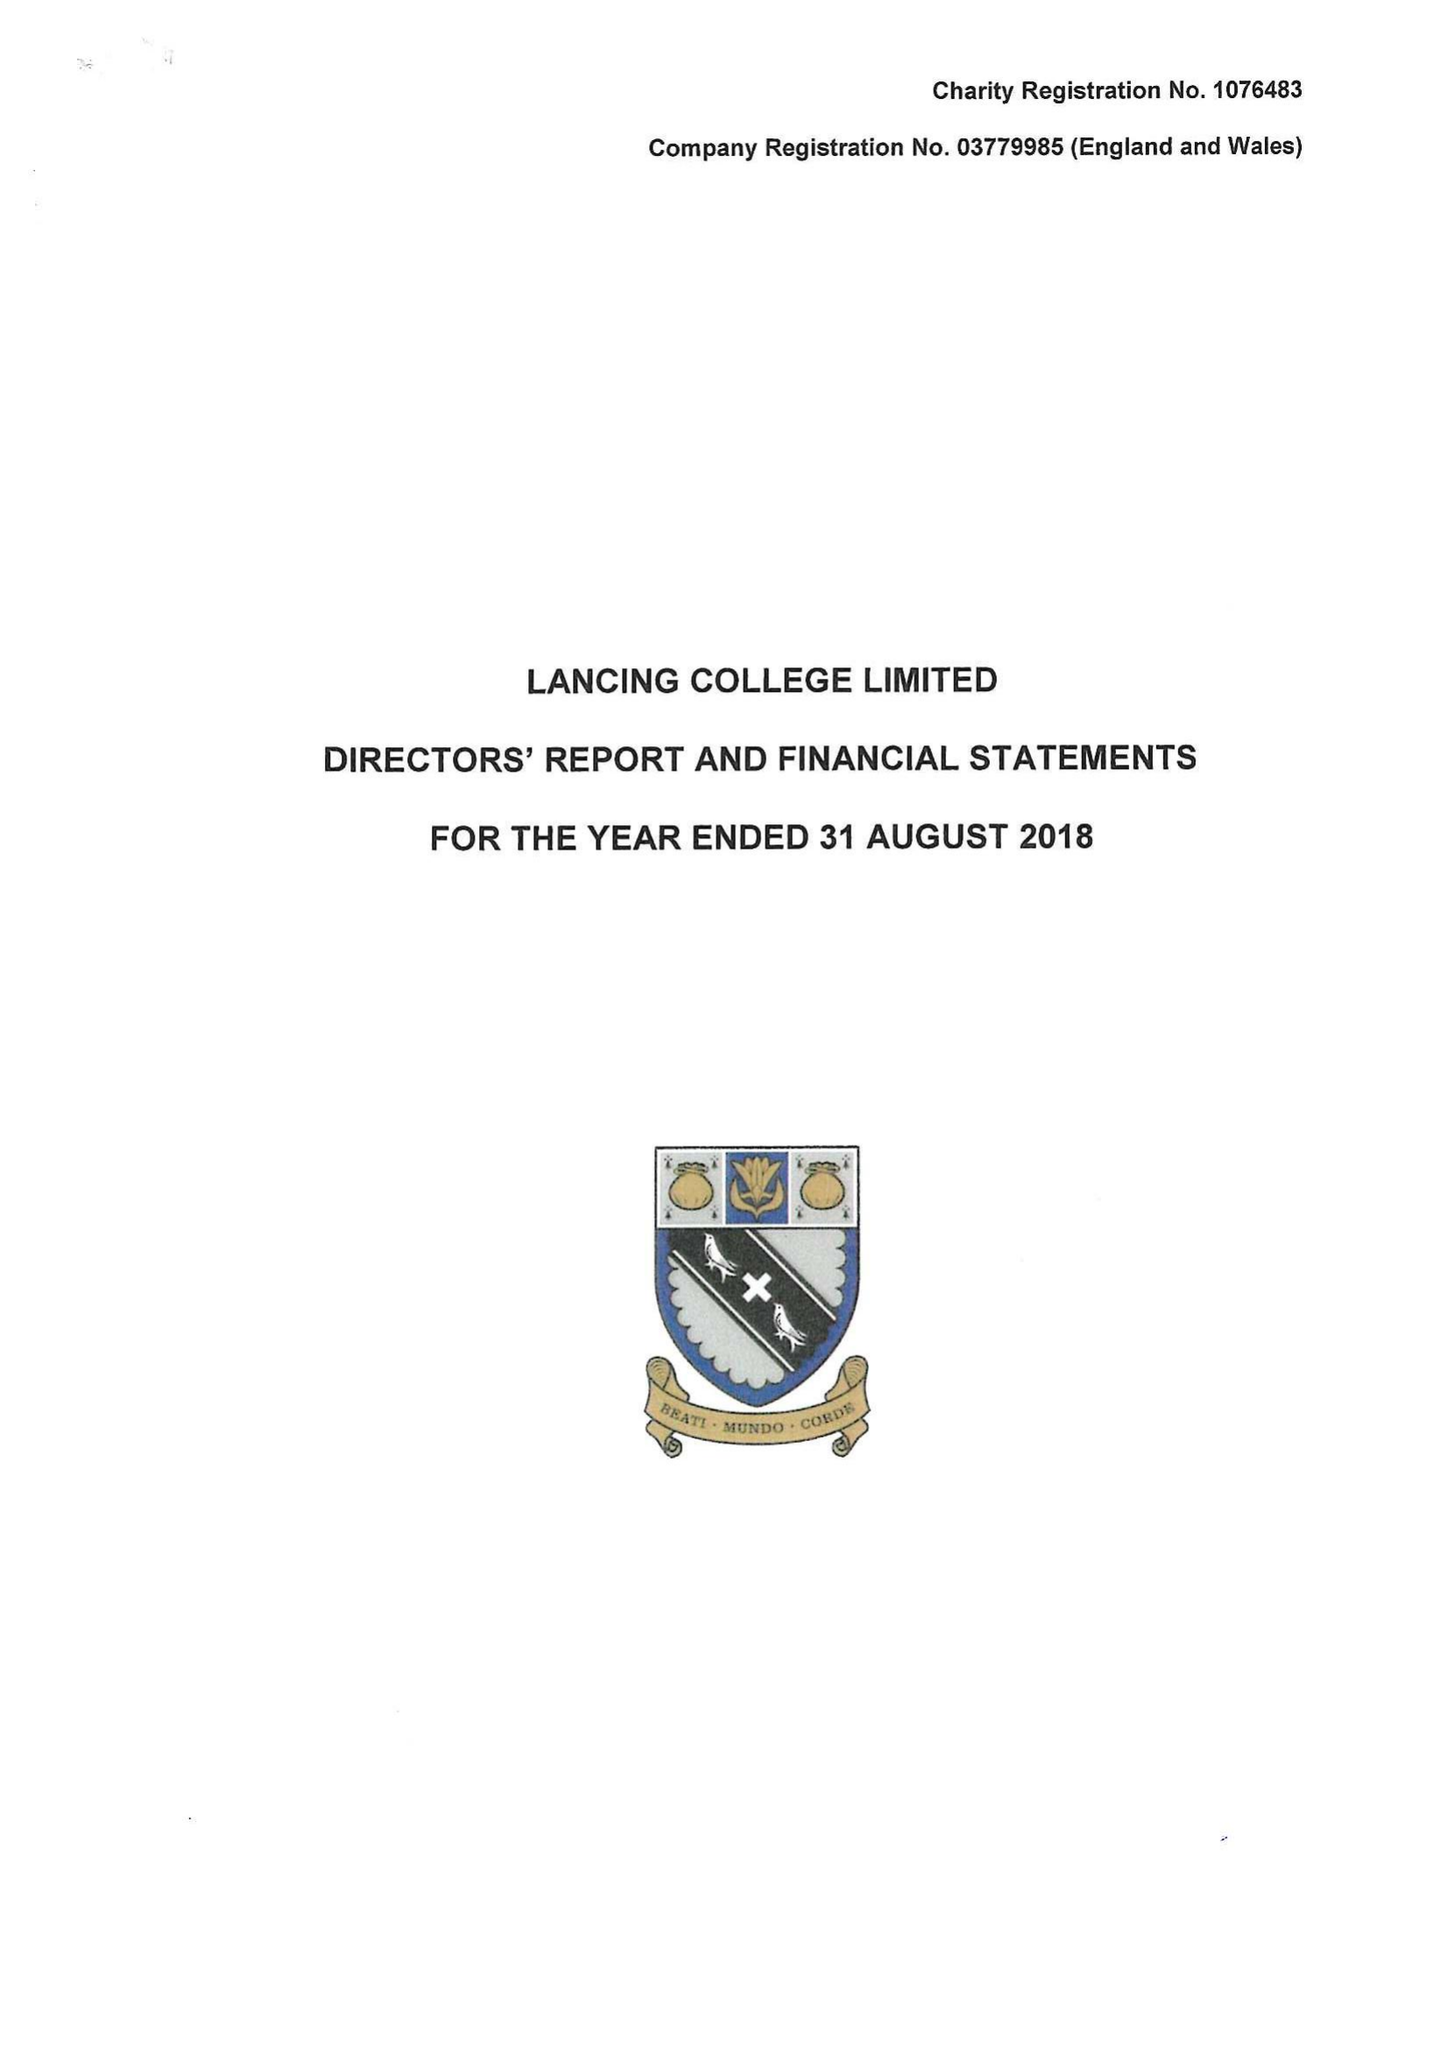What is the value for the address__postcode?
Answer the question using a single word or phrase. BN15 0RW 